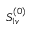Convert formula to latex. <formula><loc_0><loc_0><loc_500><loc_500>S _ { 1 v } ^ { ( 0 ) }</formula> 